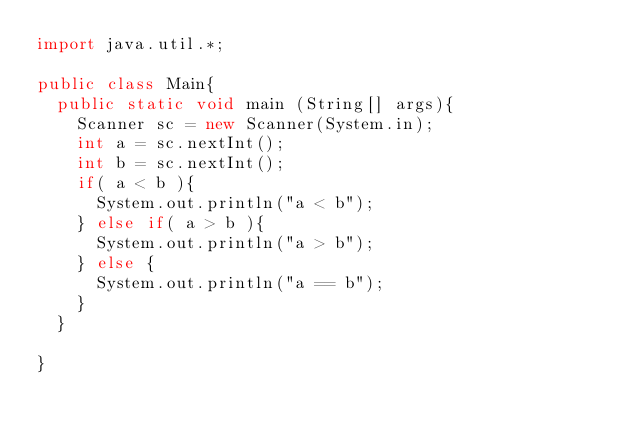<code> <loc_0><loc_0><loc_500><loc_500><_Java_>import java.util.*;

public class Main{
  public static void main (String[] args){
    Scanner sc = new Scanner(System.in);
    int a = sc.nextInt();
    int b = sc.nextInt();
    if( a < b ){
      System.out.println("a < b");
    } else if( a > b ){
      System.out.println("a > b");
    } else {
      System.out.println("a == b");
    }
  }

}
</code> 